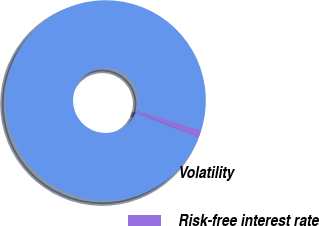Convert chart. <chart><loc_0><loc_0><loc_500><loc_500><pie_chart><fcel>Volatility<fcel>Risk-free interest rate<nl><fcel>98.86%<fcel>1.14%<nl></chart> 